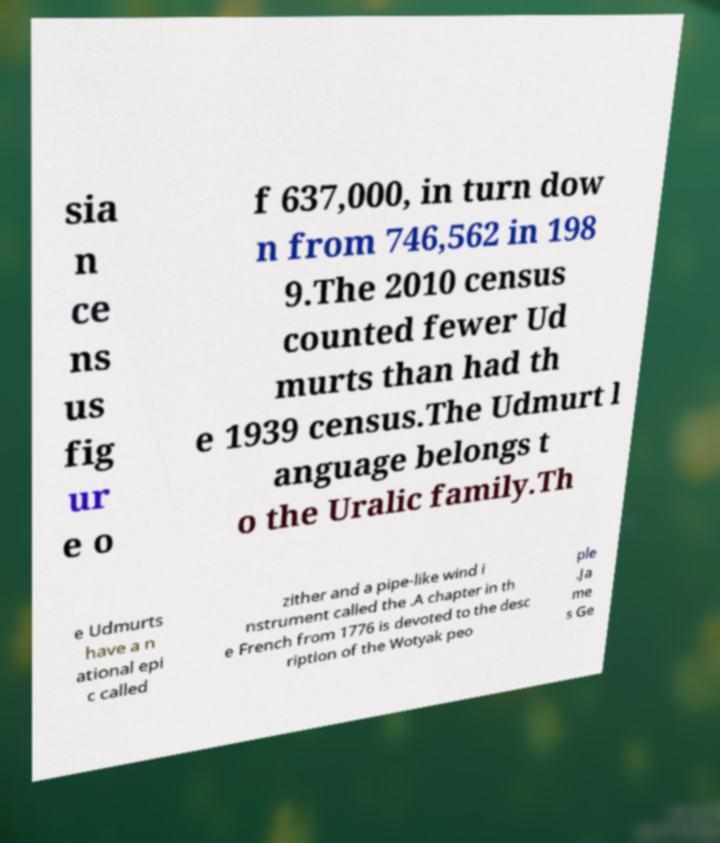Could you assist in decoding the text presented in this image and type it out clearly? sia n ce ns us fig ur e o f 637,000, in turn dow n from 746,562 in 198 9.The 2010 census counted fewer Ud murts than had th e 1939 census.The Udmurt l anguage belongs t o the Uralic family.Th e Udmurts have a n ational epi c called zither and a pipe-like wind i nstrument called the .A chapter in th e French from 1776 is devoted to the desc ription of the Wotyak peo ple .Ja me s Ge 